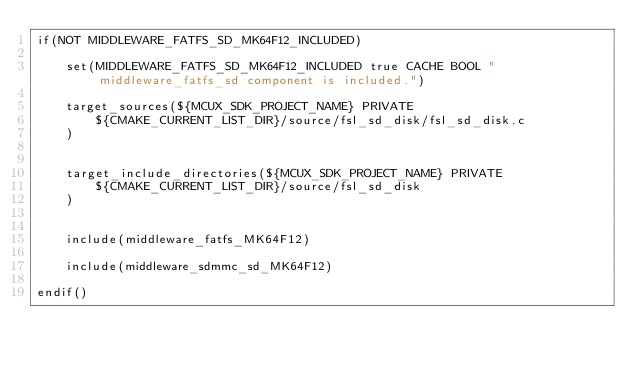<code> <loc_0><loc_0><loc_500><loc_500><_CMake_>if(NOT MIDDLEWARE_FATFS_SD_MK64F12_INCLUDED)
    
    set(MIDDLEWARE_FATFS_SD_MK64F12_INCLUDED true CACHE BOOL "middleware_fatfs_sd component is included.")

    target_sources(${MCUX_SDK_PROJECT_NAME} PRIVATE
        ${CMAKE_CURRENT_LIST_DIR}/source/fsl_sd_disk/fsl_sd_disk.c
    )


    target_include_directories(${MCUX_SDK_PROJECT_NAME} PRIVATE
        ${CMAKE_CURRENT_LIST_DIR}/source/fsl_sd_disk
    )


    include(middleware_fatfs_MK64F12)

    include(middleware_sdmmc_sd_MK64F12)

endif()
</code> 